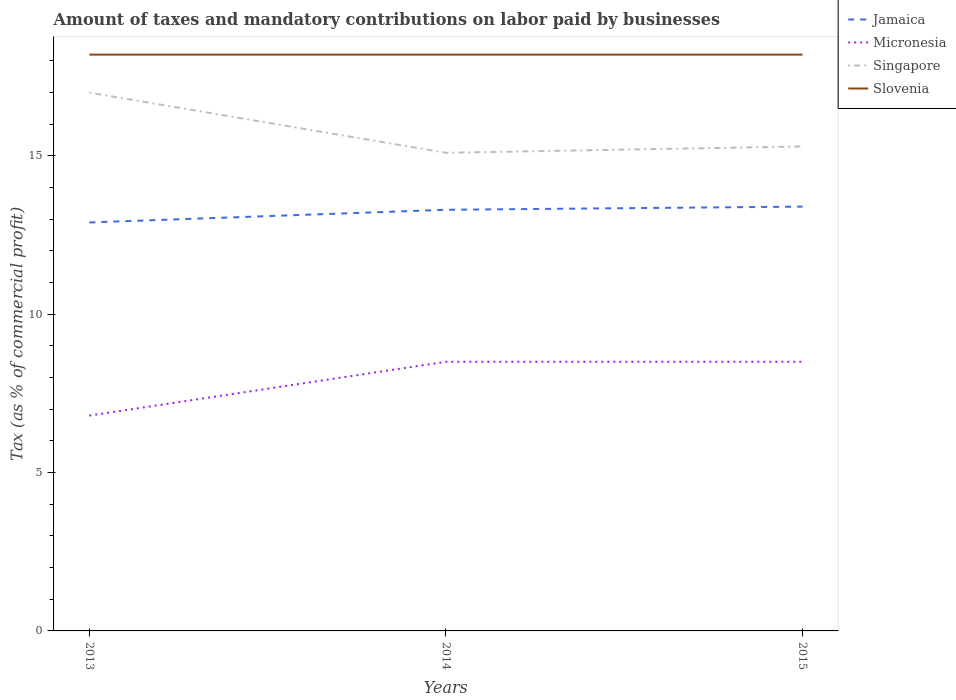Does the line corresponding to Singapore intersect with the line corresponding to Slovenia?
Offer a terse response. No. In which year was the percentage of taxes paid by businesses in Slovenia maximum?
Make the answer very short. 2013. What is the total percentage of taxes paid by businesses in Slovenia in the graph?
Provide a succinct answer. 0. What is the difference between the highest and the lowest percentage of taxes paid by businesses in Micronesia?
Your response must be concise. 2. Is the percentage of taxes paid by businesses in Singapore strictly greater than the percentage of taxes paid by businesses in Micronesia over the years?
Offer a terse response. No. How many lines are there?
Provide a succinct answer. 4. How many years are there in the graph?
Your answer should be compact. 3. What is the difference between two consecutive major ticks on the Y-axis?
Your answer should be very brief. 5. Does the graph contain any zero values?
Your response must be concise. No. What is the title of the graph?
Provide a succinct answer. Amount of taxes and mandatory contributions on labor paid by businesses. What is the label or title of the Y-axis?
Provide a short and direct response. Tax (as % of commercial profit). What is the Tax (as % of commercial profit) of Jamaica in 2013?
Make the answer very short. 12.9. What is the Tax (as % of commercial profit) of Micronesia in 2013?
Keep it short and to the point. 6.8. What is the Tax (as % of commercial profit) of Singapore in 2013?
Your response must be concise. 17. What is the Tax (as % of commercial profit) in Slovenia in 2013?
Ensure brevity in your answer.  18.2. What is the Tax (as % of commercial profit) in Jamaica in 2014?
Your response must be concise. 13.3. What is the Tax (as % of commercial profit) of Micronesia in 2014?
Provide a succinct answer. 8.5. What is the Tax (as % of commercial profit) in Slovenia in 2014?
Make the answer very short. 18.2. What is the Tax (as % of commercial profit) in Micronesia in 2015?
Provide a succinct answer. 8.5. Across all years, what is the maximum Tax (as % of commercial profit) of Singapore?
Ensure brevity in your answer.  17. Across all years, what is the maximum Tax (as % of commercial profit) in Slovenia?
Your answer should be compact. 18.2. Across all years, what is the minimum Tax (as % of commercial profit) in Jamaica?
Provide a short and direct response. 12.9. Across all years, what is the minimum Tax (as % of commercial profit) of Singapore?
Ensure brevity in your answer.  15.1. What is the total Tax (as % of commercial profit) of Jamaica in the graph?
Offer a terse response. 39.6. What is the total Tax (as % of commercial profit) in Micronesia in the graph?
Ensure brevity in your answer.  23.8. What is the total Tax (as % of commercial profit) of Singapore in the graph?
Your answer should be very brief. 47.4. What is the total Tax (as % of commercial profit) of Slovenia in the graph?
Keep it short and to the point. 54.6. What is the difference between the Tax (as % of commercial profit) of Micronesia in 2013 and that in 2014?
Your response must be concise. -1.7. What is the difference between the Tax (as % of commercial profit) of Singapore in 2013 and that in 2014?
Provide a succinct answer. 1.9. What is the difference between the Tax (as % of commercial profit) in Slovenia in 2013 and that in 2014?
Give a very brief answer. 0. What is the difference between the Tax (as % of commercial profit) of Jamaica in 2013 and that in 2015?
Your response must be concise. -0.5. What is the difference between the Tax (as % of commercial profit) in Slovenia in 2014 and that in 2015?
Your answer should be compact. 0. What is the difference between the Tax (as % of commercial profit) of Jamaica in 2013 and the Tax (as % of commercial profit) of Micronesia in 2014?
Your answer should be compact. 4.4. What is the difference between the Tax (as % of commercial profit) in Jamaica in 2013 and the Tax (as % of commercial profit) in Slovenia in 2014?
Keep it short and to the point. -5.3. What is the difference between the Tax (as % of commercial profit) of Micronesia in 2013 and the Tax (as % of commercial profit) of Singapore in 2014?
Ensure brevity in your answer.  -8.3. What is the difference between the Tax (as % of commercial profit) in Micronesia in 2013 and the Tax (as % of commercial profit) in Slovenia in 2014?
Keep it short and to the point. -11.4. What is the difference between the Tax (as % of commercial profit) in Jamaica in 2013 and the Tax (as % of commercial profit) in Micronesia in 2015?
Make the answer very short. 4.4. What is the difference between the Tax (as % of commercial profit) in Jamaica in 2013 and the Tax (as % of commercial profit) in Singapore in 2015?
Make the answer very short. -2.4. What is the difference between the Tax (as % of commercial profit) in Jamaica in 2013 and the Tax (as % of commercial profit) in Slovenia in 2015?
Your answer should be very brief. -5.3. What is the difference between the Tax (as % of commercial profit) of Micronesia in 2013 and the Tax (as % of commercial profit) of Singapore in 2015?
Your answer should be very brief. -8.5. What is the difference between the Tax (as % of commercial profit) in Micronesia in 2013 and the Tax (as % of commercial profit) in Slovenia in 2015?
Make the answer very short. -11.4. What is the difference between the Tax (as % of commercial profit) of Jamaica in 2014 and the Tax (as % of commercial profit) of Singapore in 2015?
Offer a very short reply. -2. What is the difference between the Tax (as % of commercial profit) of Micronesia in 2014 and the Tax (as % of commercial profit) of Singapore in 2015?
Provide a short and direct response. -6.8. What is the difference between the Tax (as % of commercial profit) of Singapore in 2014 and the Tax (as % of commercial profit) of Slovenia in 2015?
Offer a terse response. -3.1. What is the average Tax (as % of commercial profit) in Micronesia per year?
Give a very brief answer. 7.93. In the year 2013, what is the difference between the Tax (as % of commercial profit) of Micronesia and Tax (as % of commercial profit) of Singapore?
Your answer should be compact. -10.2. In the year 2014, what is the difference between the Tax (as % of commercial profit) in Micronesia and Tax (as % of commercial profit) in Slovenia?
Your response must be concise. -9.7. In the year 2014, what is the difference between the Tax (as % of commercial profit) of Singapore and Tax (as % of commercial profit) of Slovenia?
Your answer should be compact. -3.1. In the year 2015, what is the difference between the Tax (as % of commercial profit) of Jamaica and Tax (as % of commercial profit) of Micronesia?
Ensure brevity in your answer.  4.9. In the year 2015, what is the difference between the Tax (as % of commercial profit) in Micronesia and Tax (as % of commercial profit) in Singapore?
Your answer should be compact. -6.8. In the year 2015, what is the difference between the Tax (as % of commercial profit) in Micronesia and Tax (as % of commercial profit) in Slovenia?
Your answer should be compact. -9.7. What is the ratio of the Tax (as % of commercial profit) in Jamaica in 2013 to that in 2014?
Keep it short and to the point. 0.97. What is the ratio of the Tax (as % of commercial profit) in Micronesia in 2013 to that in 2014?
Provide a short and direct response. 0.8. What is the ratio of the Tax (as % of commercial profit) of Singapore in 2013 to that in 2014?
Give a very brief answer. 1.13. What is the ratio of the Tax (as % of commercial profit) of Jamaica in 2013 to that in 2015?
Give a very brief answer. 0.96. What is the ratio of the Tax (as % of commercial profit) of Singapore in 2013 to that in 2015?
Keep it short and to the point. 1.11. What is the ratio of the Tax (as % of commercial profit) in Slovenia in 2013 to that in 2015?
Make the answer very short. 1. What is the ratio of the Tax (as % of commercial profit) in Jamaica in 2014 to that in 2015?
Your response must be concise. 0.99. What is the ratio of the Tax (as % of commercial profit) in Singapore in 2014 to that in 2015?
Your answer should be very brief. 0.99. What is the difference between the highest and the second highest Tax (as % of commercial profit) in Jamaica?
Give a very brief answer. 0.1. What is the difference between the highest and the second highest Tax (as % of commercial profit) in Micronesia?
Your answer should be very brief. 0. What is the difference between the highest and the lowest Tax (as % of commercial profit) of Jamaica?
Offer a terse response. 0.5. What is the difference between the highest and the lowest Tax (as % of commercial profit) of Micronesia?
Offer a very short reply. 1.7. 